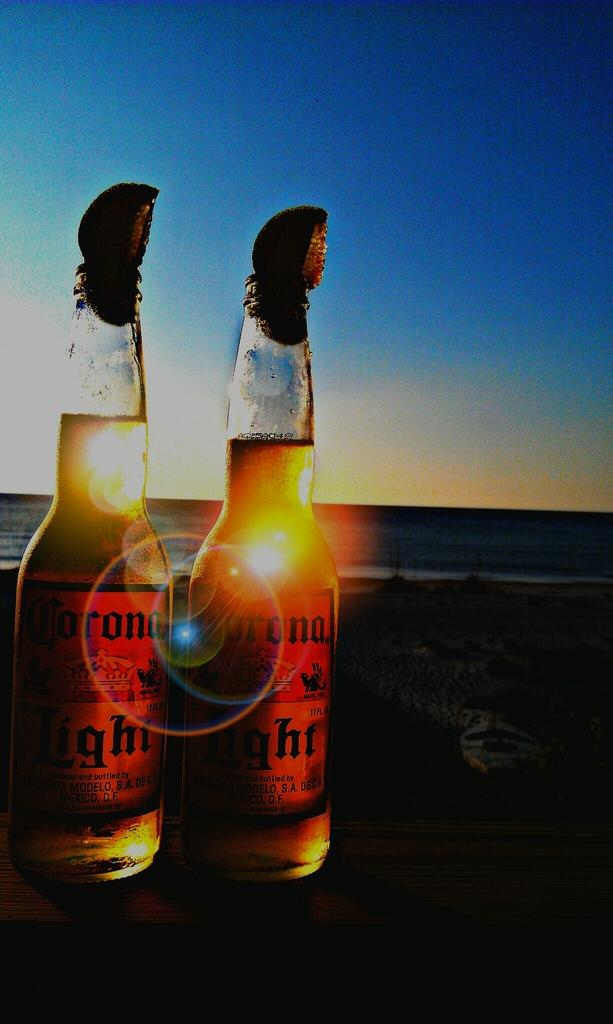<image>
Offer a succinct explanation of the picture presented. TWO BOTTLES OF CORONA LIGHTS SITTING ON A TABLE ON THE BEACH 